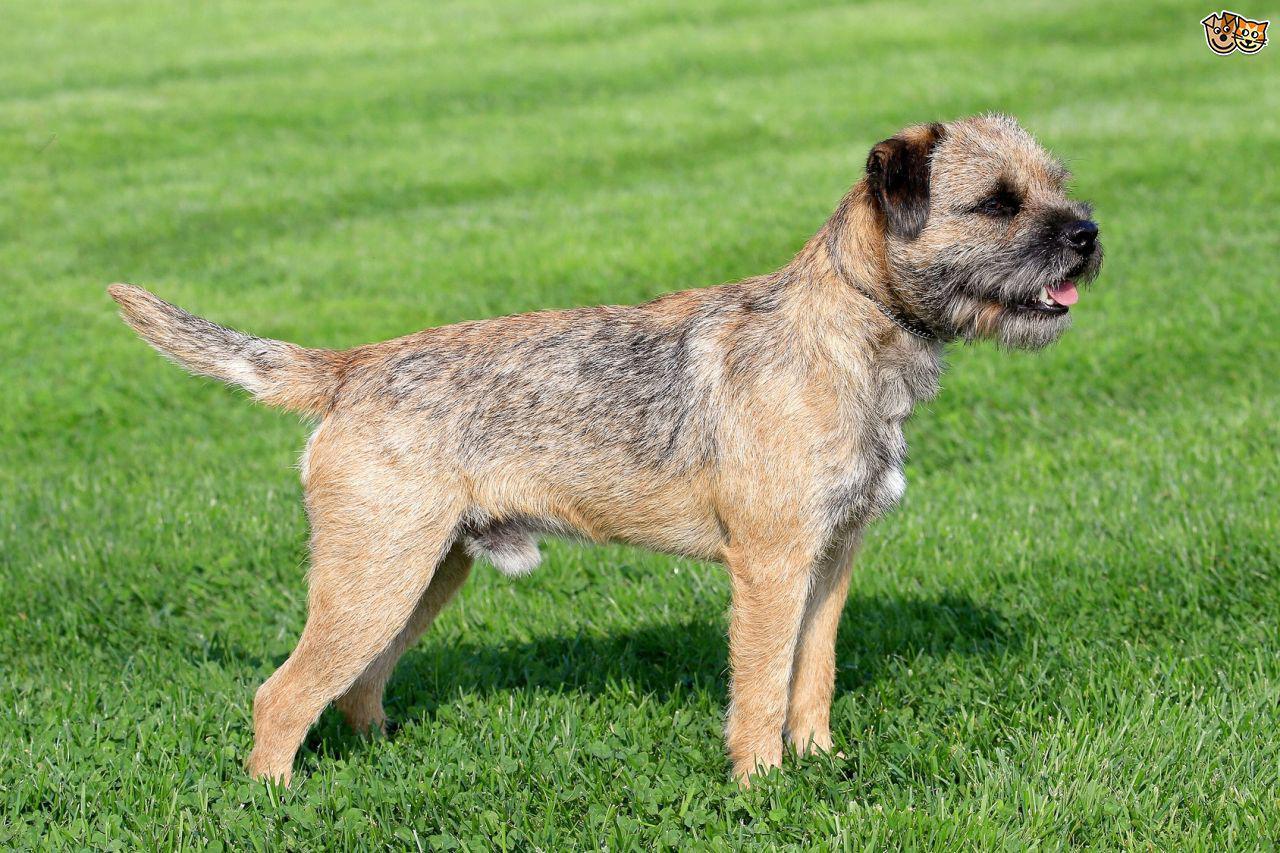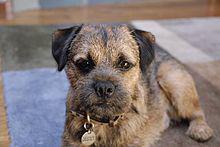The first image is the image on the left, the second image is the image on the right. Considering the images on both sides, is "At least one dog is wearing a red collar." valid? Answer yes or no. No. The first image is the image on the left, the second image is the image on the right. Assess this claim about the two images: "At least one dog is wearing a red collar.". Correct or not? Answer yes or no. No. 